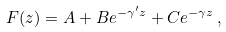<formula> <loc_0><loc_0><loc_500><loc_500>F ( z ) = A + B e ^ { - \gamma ^ { \prime } z } + C e ^ { - \gamma z } \, ,</formula> 